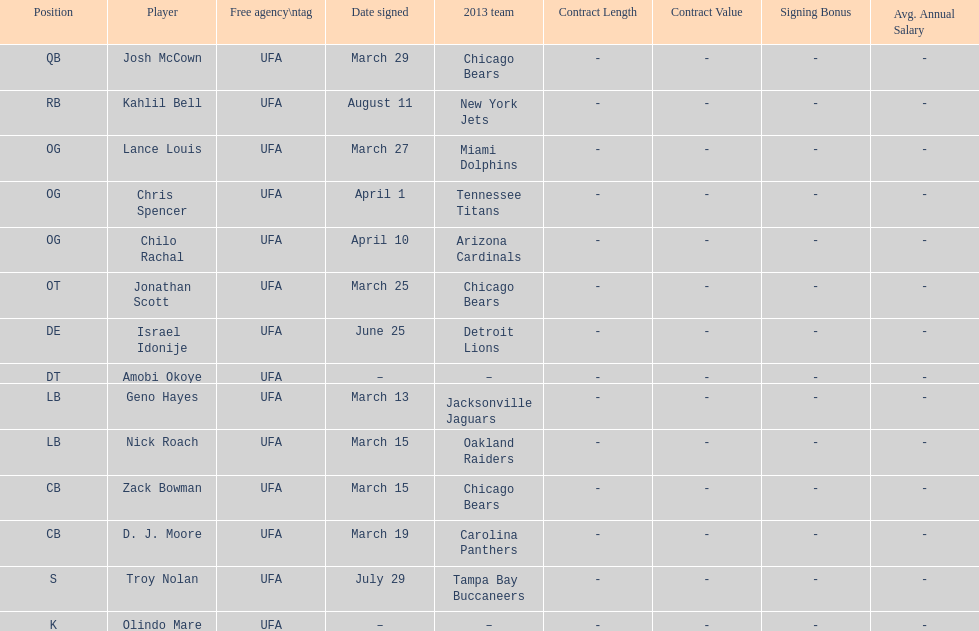The top played position according to this chart. OG. 